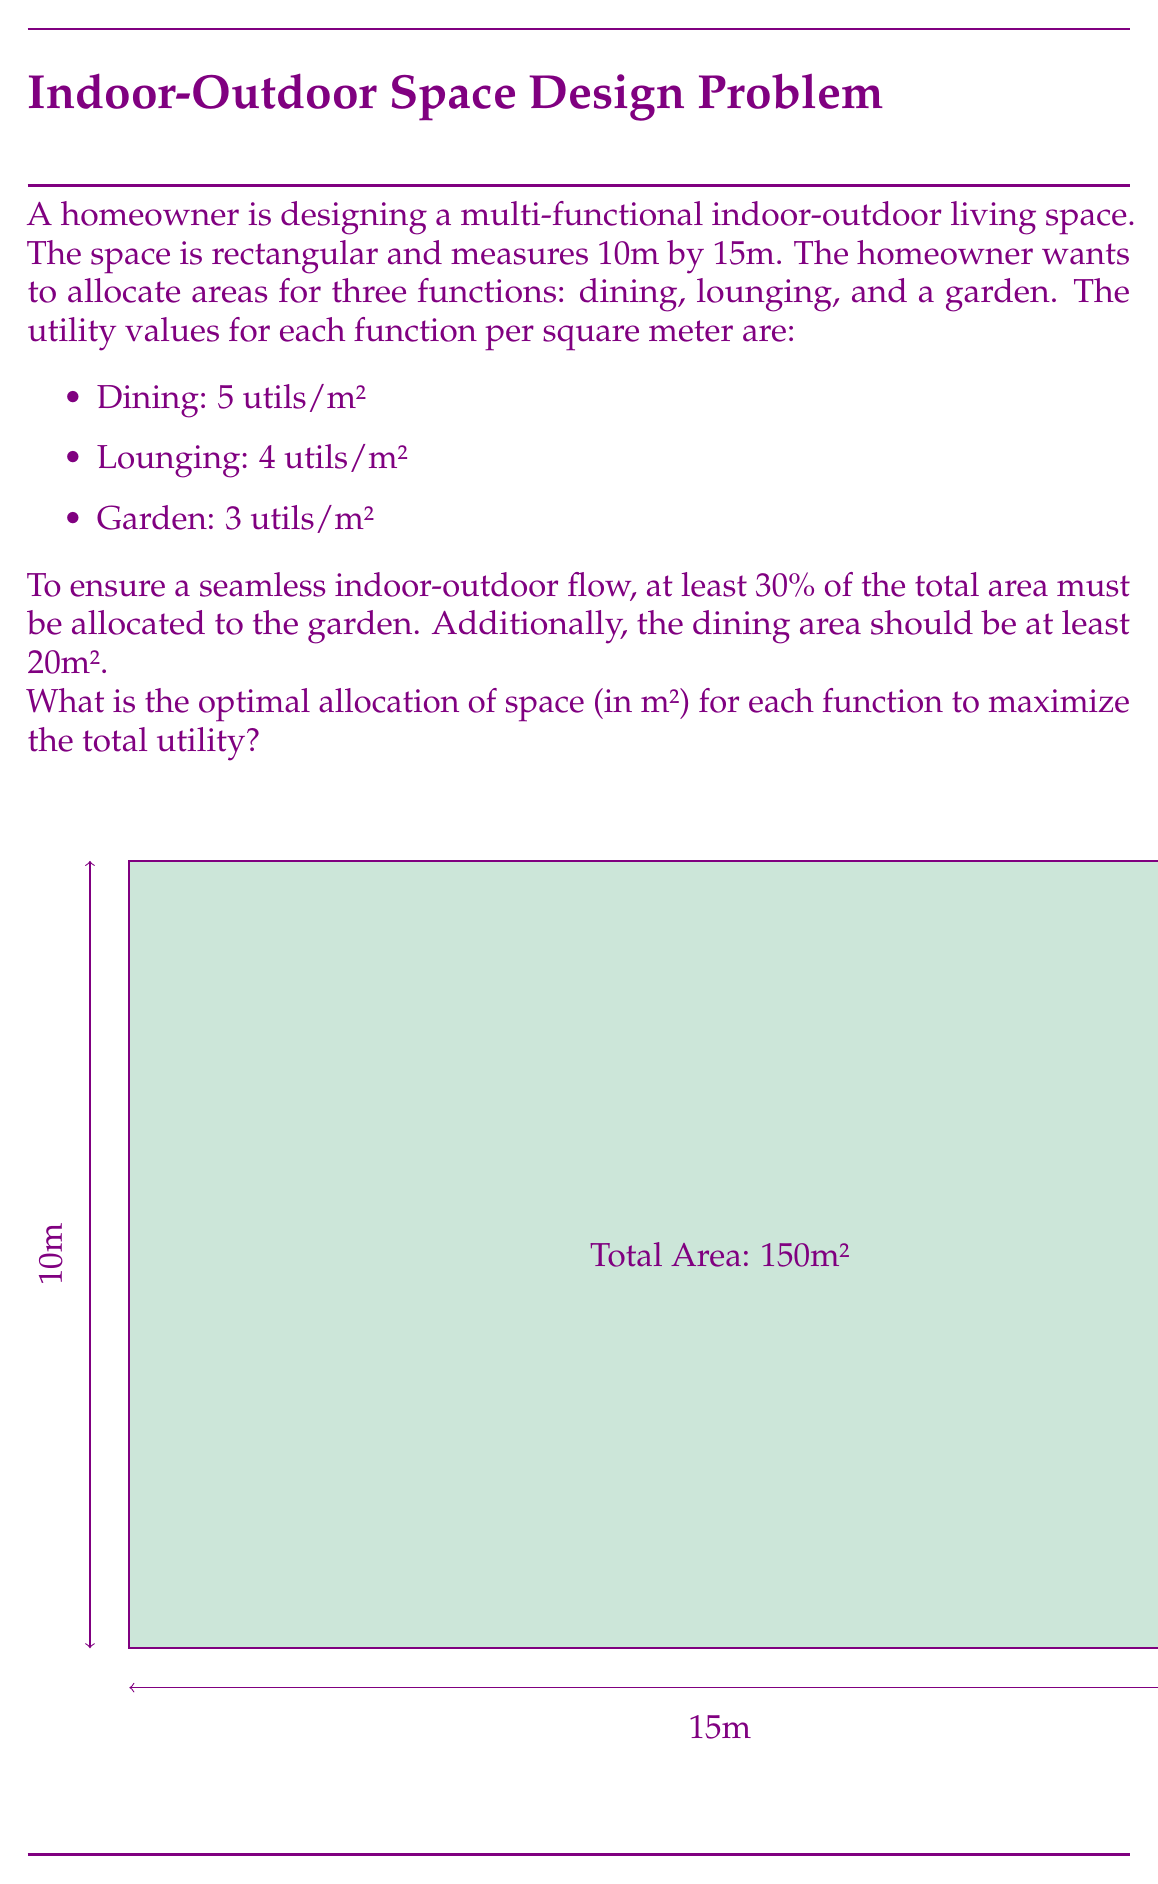Teach me how to tackle this problem. Let's approach this step-by-step using linear programming:

1) Define variables:
   $x$ = dining area (m²)
   $y$ = lounging area (m²)
   $z$ = garden area (m²)

2) Objective function (maximize total utility):
   $$\text{Maximize } U = 5x + 4y + 3z$$

3) Constraints:
   a) Total area: $x + y + z = 150$ (10m × 15m = 150m²)
   b) Garden area (at least 30%): $z \geq 0.3(150) = 45$
   c) Dining area (at least 20m²): $x \geq 20$
   d) Non-negativity: $x, y, z \geq 0$

4) Solve using the simplex method or optimization software. However, we can deduce the optimal solution logically:

   - The dining area should be at its minimum (20m²) as it has the highest utility per m².
   - The garden should be at its minimum (45m²) as it has the lowest utility per m².
   - The remaining area should be allocated to lounging:
     $150 - 20 - 45 = 85$ m²

5) Verify the solution:
   Total utility = $5(20) + 4(85) + 3(45) = 100 + 340 + 135 = 575$ utils

This allocation maximizes utility while meeting all constraints.
Answer: Dining: 20m², Lounging: 85m², Garden: 45m² 